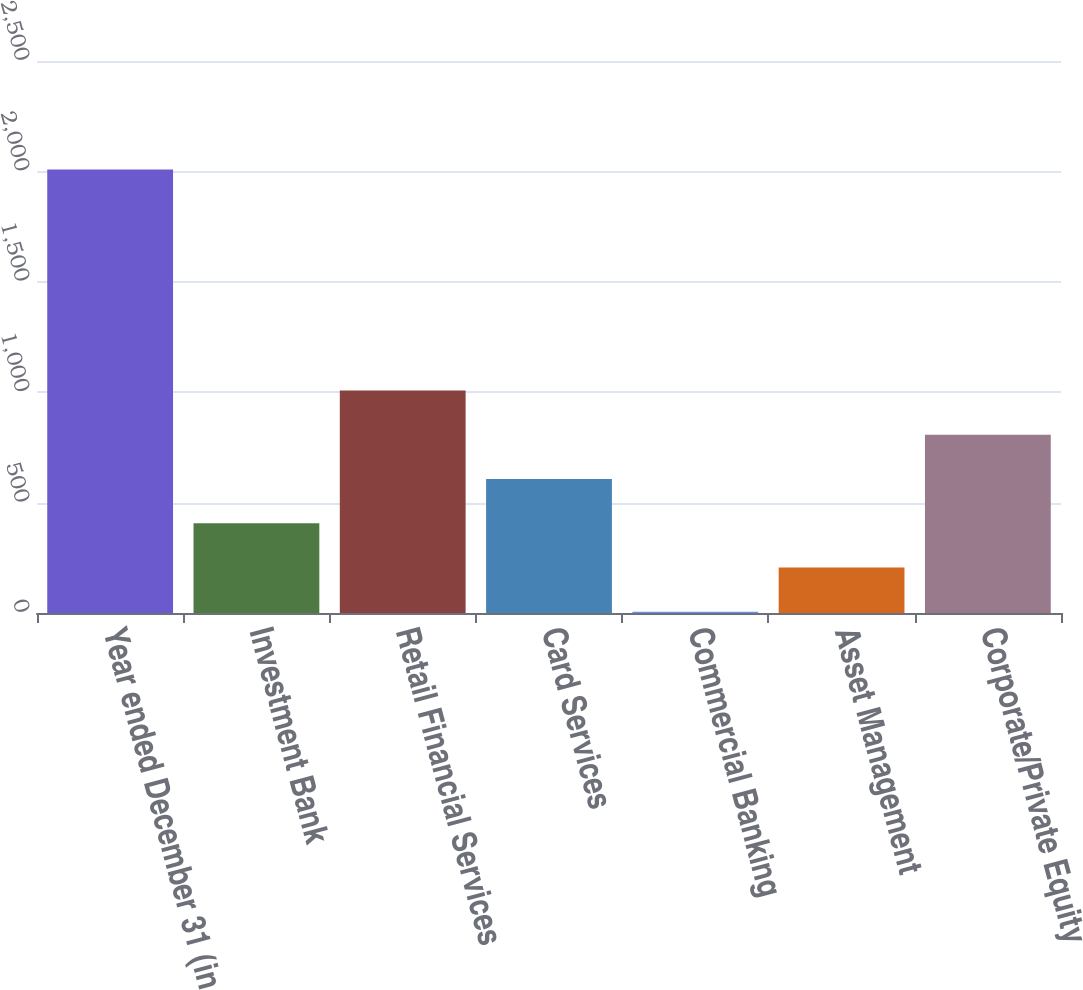Convert chart. <chart><loc_0><loc_0><loc_500><loc_500><bar_chart><fcel>Year ended December 31 (in<fcel>Investment Bank<fcel>Retail Financial Services<fcel>Card Services<fcel>Commercial Banking<fcel>Asset Management<fcel>Corporate/Private Equity<nl><fcel>2009<fcel>406.6<fcel>1007.5<fcel>606.9<fcel>6<fcel>206.3<fcel>807.2<nl></chart> 